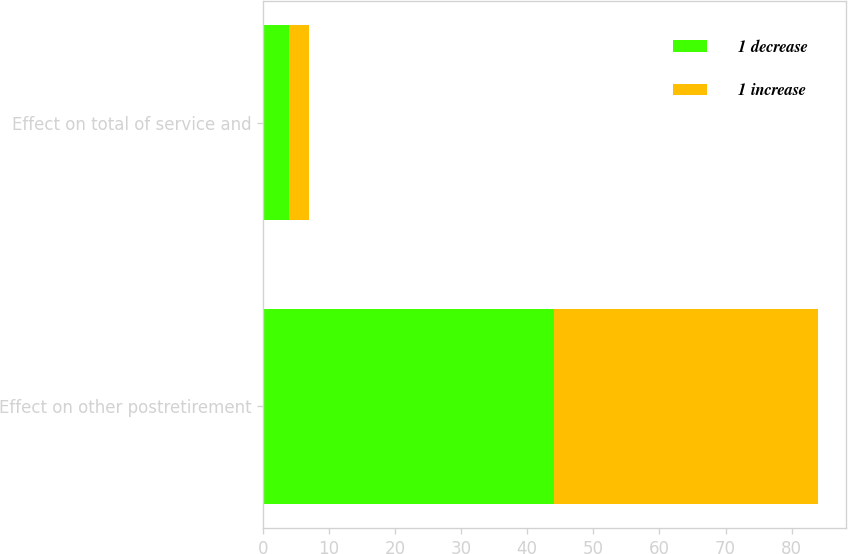Convert chart to OTSL. <chart><loc_0><loc_0><loc_500><loc_500><stacked_bar_chart><ecel><fcel>Effect on other postretirement<fcel>Effect on total of service and<nl><fcel>1 decrease<fcel>44<fcel>4<nl><fcel>1 increase<fcel>40<fcel>3<nl></chart> 